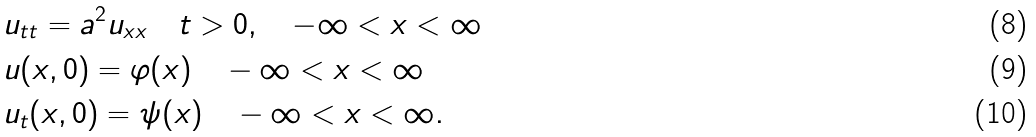<formula> <loc_0><loc_0><loc_500><loc_500>& u _ { t t } = a ^ { 2 } u _ { x x } \quad t > 0 , \quad - \infty < x < \infty \\ & u ( x , 0 ) = \varphi ( x ) \quad - \infty < x < \infty \\ & u _ { t } ( x , 0 ) = \psi ( x ) \quad - \infty < x < \infty .</formula> 